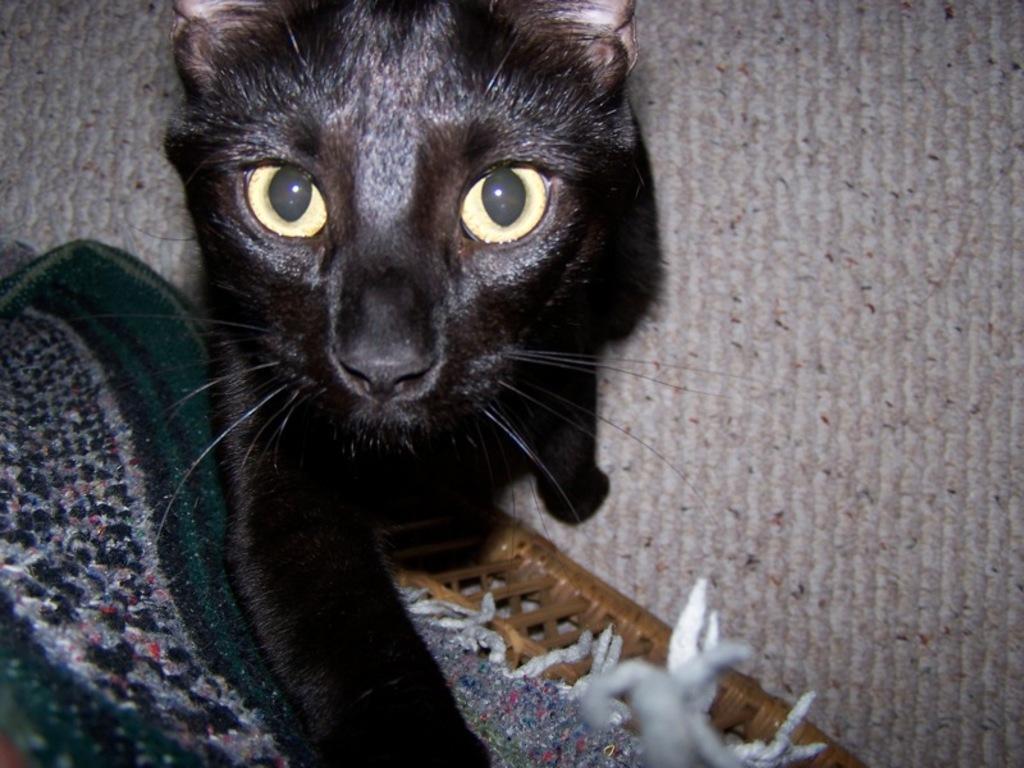In one or two sentences, can you explain what this image depicts? In this image we can see a cat on the surface. On the left side of the image we can see a cloth placed on a stool. 